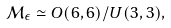<formula> <loc_0><loc_0><loc_500><loc_500>\mathcal { M } _ { \epsilon } \simeq O ( 6 , 6 ) / U ( 3 , 3 ) ,</formula> 